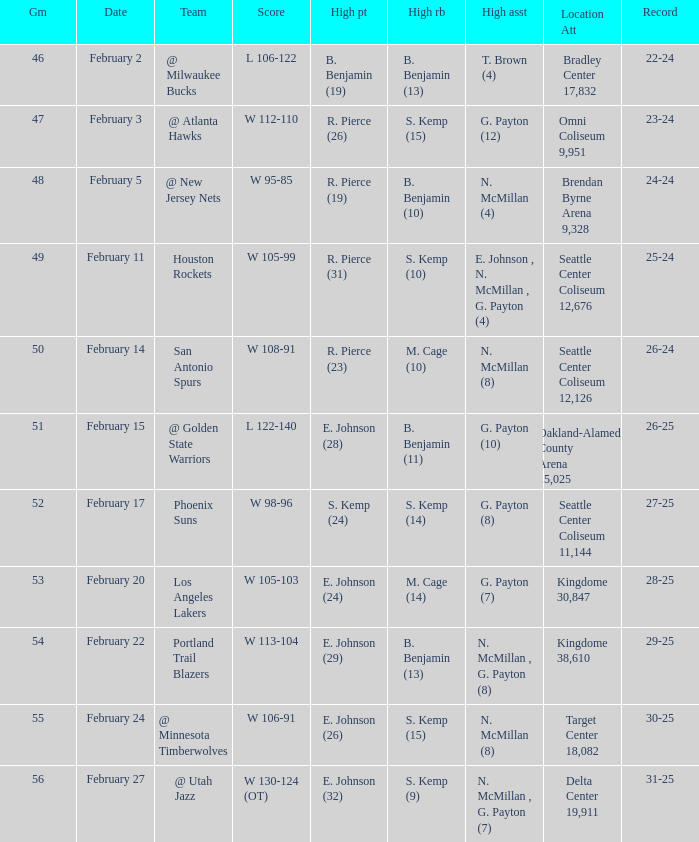What date was the game played in seattle center coliseum 12,126? February 14. 